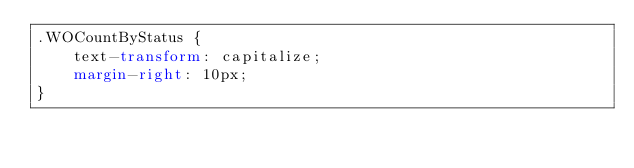<code> <loc_0><loc_0><loc_500><loc_500><_CSS_>.WOCountByStatus {
    text-transform: capitalize;
    margin-right: 10px;
}</code> 